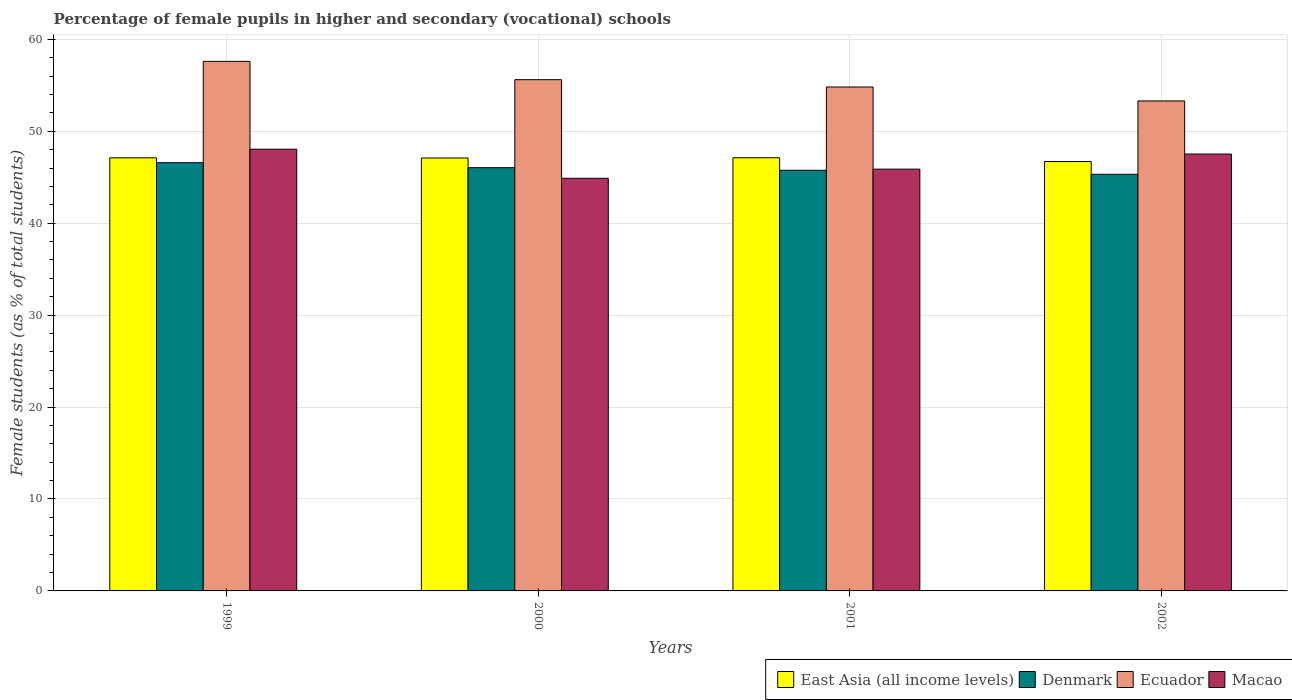Are the number of bars on each tick of the X-axis equal?
Offer a very short reply. Yes. How many bars are there on the 4th tick from the left?
Your response must be concise. 4. In how many cases, is the number of bars for a given year not equal to the number of legend labels?
Keep it short and to the point. 0. What is the percentage of female pupils in higher and secondary schools in Denmark in 2001?
Make the answer very short. 45.76. Across all years, what is the maximum percentage of female pupils in higher and secondary schools in Macao?
Make the answer very short. 48.05. Across all years, what is the minimum percentage of female pupils in higher and secondary schools in East Asia (all income levels)?
Keep it short and to the point. 46.71. In which year was the percentage of female pupils in higher and secondary schools in Ecuador maximum?
Your answer should be very brief. 1999. What is the total percentage of female pupils in higher and secondary schools in East Asia (all income levels) in the graph?
Give a very brief answer. 188.05. What is the difference between the percentage of female pupils in higher and secondary schools in Ecuador in 1999 and that in 2000?
Offer a very short reply. 1.99. What is the difference between the percentage of female pupils in higher and secondary schools in East Asia (all income levels) in 2000 and the percentage of female pupils in higher and secondary schools in Denmark in 2002?
Offer a very short reply. 1.77. What is the average percentage of female pupils in higher and secondary schools in Macao per year?
Your answer should be compact. 46.59. In the year 1999, what is the difference between the percentage of female pupils in higher and secondary schools in Denmark and percentage of female pupils in higher and secondary schools in Macao?
Your answer should be very brief. -1.47. What is the ratio of the percentage of female pupils in higher and secondary schools in Macao in 1999 to that in 2000?
Provide a short and direct response. 1.07. Is the percentage of female pupils in higher and secondary schools in East Asia (all income levels) in 2000 less than that in 2001?
Give a very brief answer. Yes. Is the difference between the percentage of female pupils in higher and secondary schools in Denmark in 2000 and 2002 greater than the difference between the percentage of female pupils in higher and secondary schools in Macao in 2000 and 2002?
Your answer should be compact. Yes. What is the difference between the highest and the second highest percentage of female pupils in higher and secondary schools in Denmark?
Keep it short and to the point. 0.54. What is the difference between the highest and the lowest percentage of female pupils in higher and secondary schools in Ecuador?
Your answer should be compact. 4.31. In how many years, is the percentage of female pupils in higher and secondary schools in Denmark greater than the average percentage of female pupils in higher and secondary schools in Denmark taken over all years?
Give a very brief answer. 2. How many bars are there?
Your response must be concise. 16. Are all the bars in the graph horizontal?
Give a very brief answer. No. How many years are there in the graph?
Your answer should be compact. 4. Does the graph contain any zero values?
Make the answer very short. No. Where does the legend appear in the graph?
Keep it short and to the point. Bottom right. How are the legend labels stacked?
Ensure brevity in your answer.  Horizontal. What is the title of the graph?
Your answer should be very brief. Percentage of female pupils in higher and secondary (vocational) schools. What is the label or title of the Y-axis?
Offer a terse response. Female students (as % of total students). What is the Female students (as % of total students) of East Asia (all income levels) in 1999?
Your response must be concise. 47.11. What is the Female students (as % of total students) in Denmark in 1999?
Your answer should be compact. 46.58. What is the Female students (as % of total students) in Ecuador in 1999?
Your answer should be very brief. 57.61. What is the Female students (as % of total students) in Macao in 1999?
Give a very brief answer. 48.05. What is the Female students (as % of total students) in East Asia (all income levels) in 2000?
Ensure brevity in your answer.  47.1. What is the Female students (as % of total students) of Denmark in 2000?
Keep it short and to the point. 46.04. What is the Female students (as % of total students) in Ecuador in 2000?
Give a very brief answer. 55.62. What is the Female students (as % of total students) in Macao in 2000?
Your response must be concise. 44.89. What is the Female students (as % of total students) of East Asia (all income levels) in 2001?
Offer a terse response. 47.12. What is the Female students (as % of total students) of Denmark in 2001?
Provide a succinct answer. 45.76. What is the Female students (as % of total students) in Ecuador in 2001?
Offer a very short reply. 54.82. What is the Female students (as % of total students) in Macao in 2001?
Your response must be concise. 45.88. What is the Female students (as % of total students) in East Asia (all income levels) in 2002?
Offer a very short reply. 46.71. What is the Female students (as % of total students) in Denmark in 2002?
Give a very brief answer. 45.32. What is the Female students (as % of total students) of Ecuador in 2002?
Offer a terse response. 53.3. What is the Female students (as % of total students) in Macao in 2002?
Make the answer very short. 47.53. Across all years, what is the maximum Female students (as % of total students) in East Asia (all income levels)?
Provide a short and direct response. 47.12. Across all years, what is the maximum Female students (as % of total students) of Denmark?
Provide a short and direct response. 46.58. Across all years, what is the maximum Female students (as % of total students) in Ecuador?
Keep it short and to the point. 57.61. Across all years, what is the maximum Female students (as % of total students) of Macao?
Provide a short and direct response. 48.05. Across all years, what is the minimum Female students (as % of total students) in East Asia (all income levels)?
Keep it short and to the point. 46.71. Across all years, what is the minimum Female students (as % of total students) in Denmark?
Provide a succinct answer. 45.32. Across all years, what is the minimum Female students (as % of total students) in Ecuador?
Keep it short and to the point. 53.3. Across all years, what is the minimum Female students (as % of total students) of Macao?
Ensure brevity in your answer.  44.89. What is the total Female students (as % of total students) in East Asia (all income levels) in the graph?
Offer a very short reply. 188.05. What is the total Female students (as % of total students) in Denmark in the graph?
Provide a short and direct response. 183.71. What is the total Female students (as % of total students) of Ecuador in the graph?
Offer a terse response. 221.35. What is the total Female students (as % of total students) in Macao in the graph?
Make the answer very short. 186.35. What is the difference between the Female students (as % of total students) in East Asia (all income levels) in 1999 and that in 2000?
Make the answer very short. 0.02. What is the difference between the Female students (as % of total students) of Denmark in 1999 and that in 2000?
Your answer should be compact. 0.54. What is the difference between the Female students (as % of total students) in Ecuador in 1999 and that in 2000?
Offer a very short reply. 1.99. What is the difference between the Female students (as % of total students) of Macao in 1999 and that in 2000?
Provide a succinct answer. 3.17. What is the difference between the Female students (as % of total students) of East Asia (all income levels) in 1999 and that in 2001?
Your response must be concise. -0.01. What is the difference between the Female students (as % of total students) in Denmark in 1999 and that in 2001?
Your answer should be compact. 0.83. What is the difference between the Female students (as % of total students) in Ecuador in 1999 and that in 2001?
Provide a short and direct response. 2.79. What is the difference between the Female students (as % of total students) of Macao in 1999 and that in 2001?
Your response must be concise. 2.17. What is the difference between the Female students (as % of total students) of East Asia (all income levels) in 1999 and that in 2002?
Give a very brief answer. 0.4. What is the difference between the Female students (as % of total students) in Denmark in 1999 and that in 2002?
Make the answer very short. 1.26. What is the difference between the Female students (as % of total students) of Ecuador in 1999 and that in 2002?
Give a very brief answer. 4.31. What is the difference between the Female students (as % of total students) in Macao in 1999 and that in 2002?
Make the answer very short. 0.53. What is the difference between the Female students (as % of total students) of East Asia (all income levels) in 2000 and that in 2001?
Make the answer very short. -0.03. What is the difference between the Female students (as % of total students) in Denmark in 2000 and that in 2001?
Ensure brevity in your answer.  0.28. What is the difference between the Female students (as % of total students) of Ecuador in 2000 and that in 2001?
Your answer should be very brief. 0.8. What is the difference between the Female students (as % of total students) in Macao in 2000 and that in 2001?
Your answer should be compact. -1. What is the difference between the Female students (as % of total students) of East Asia (all income levels) in 2000 and that in 2002?
Keep it short and to the point. 0.38. What is the difference between the Female students (as % of total students) of Denmark in 2000 and that in 2002?
Provide a succinct answer. 0.72. What is the difference between the Female students (as % of total students) in Ecuador in 2000 and that in 2002?
Keep it short and to the point. 2.31. What is the difference between the Female students (as % of total students) of Macao in 2000 and that in 2002?
Offer a very short reply. -2.64. What is the difference between the Female students (as % of total students) of East Asia (all income levels) in 2001 and that in 2002?
Provide a short and direct response. 0.41. What is the difference between the Female students (as % of total students) in Denmark in 2001 and that in 2002?
Your answer should be very brief. 0.44. What is the difference between the Female students (as % of total students) of Ecuador in 2001 and that in 2002?
Make the answer very short. 1.52. What is the difference between the Female students (as % of total students) of Macao in 2001 and that in 2002?
Provide a succinct answer. -1.64. What is the difference between the Female students (as % of total students) of East Asia (all income levels) in 1999 and the Female students (as % of total students) of Denmark in 2000?
Provide a short and direct response. 1.07. What is the difference between the Female students (as % of total students) of East Asia (all income levels) in 1999 and the Female students (as % of total students) of Ecuador in 2000?
Ensure brevity in your answer.  -8.5. What is the difference between the Female students (as % of total students) of East Asia (all income levels) in 1999 and the Female students (as % of total students) of Macao in 2000?
Offer a very short reply. 2.23. What is the difference between the Female students (as % of total students) in Denmark in 1999 and the Female students (as % of total students) in Ecuador in 2000?
Offer a terse response. -9.03. What is the difference between the Female students (as % of total students) in Denmark in 1999 and the Female students (as % of total students) in Macao in 2000?
Your response must be concise. 1.7. What is the difference between the Female students (as % of total students) of Ecuador in 1999 and the Female students (as % of total students) of Macao in 2000?
Your answer should be compact. 12.72. What is the difference between the Female students (as % of total students) of East Asia (all income levels) in 1999 and the Female students (as % of total students) of Denmark in 2001?
Offer a terse response. 1.35. What is the difference between the Female students (as % of total students) in East Asia (all income levels) in 1999 and the Female students (as % of total students) in Ecuador in 2001?
Ensure brevity in your answer.  -7.71. What is the difference between the Female students (as % of total students) in East Asia (all income levels) in 1999 and the Female students (as % of total students) in Macao in 2001?
Ensure brevity in your answer.  1.23. What is the difference between the Female students (as % of total students) of Denmark in 1999 and the Female students (as % of total students) of Ecuador in 2001?
Give a very brief answer. -8.24. What is the difference between the Female students (as % of total students) in Denmark in 1999 and the Female students (as % of total students) in Macao in 2001?
Your answer should be compact. 0.7. What is the difference between the Female students (as % of total students) in Ecuador in 1999 and the Female students (as % of total students) in Macao in 2001?
Keep it short and to the point. 11.72. What is the difference between the Female students (as % of total students) of East Asia (all income levels) in 1999 and the Female students (as % of total students) of Denmark in 2002?
Offer a terse response. 1.79. What is the difference between the Female students (as % of total students) of East Asia (all income levels) in 1999 and the Female students (as % of total students) of Ecuador in 2002?
Keep it short and to the point. -6.19. What is the difference between the Female students (as % of total students) in East Asia (all income levels) in 1999 and the Female students (as % of total students) in Macao in 2002?
Provide a short and direct response. -0.41. What is the difference between the Female students (as % of total students) of Denmark in 1999 and the Female students (as % of total students) of Ecuador in 2002?
Give a very brief answer. -6.72. What is the difference between the Female students (as % of total students) of Denmark in 1999 and the Female students (as % of total students) of Macao in 2002?
Your answer should be very brief. -0.94. What is the difference between the Female students (as % of total students) of Ecuador in 1999 and the Female students (as % of total students) of Macao in 2002?
Your response must be concise. 10.08. What is the difference between the Female students (as % of total students) in East Asia (all income levels) in 2000 and the Female students (as % of total students) in Denmark in 2001?
Your answer should be compact. 1.34. What is the difference between the Female students (as % of total students) in East Asia (all income levels) in 2000 and the Female students (as % of total students) in Ecuador in 2001?
Provide a succinct answer. -7.72. What is the difference between the Female students (as % of total students) in East Asia (all income levels) in 2000 and the Female students (as % of total students) in Macao in 2001?
Give a very brief answer. 1.21. What is the difference between the Female students (as % of total students) of Denmark in 2000 and the Female students (as % of total students) of Ecuador in 2001?
Make the answer very short. -8.78. What is the difference between the Female students (as % of total students) in Denmark in 2000 and the Female students (as % of total students) in Macao in 2001?
Keep it short and to the point. 0.16. What is the difference between the Female students (as % of total students) of Ecuador in 2000 and the Female students (as % of total students) of Macao in 2001?
Ensure brevity in your answer.  9.73. What is the difference between the Female students (as % of total students) in East Asia (all income levels) in 2000 and the Female students (as % of total students) in Denmark in 2002?
Keep it short and to the point. 1.77. What is the difference between the Female students (as % of total students) of East Asia (all income levels) in 2000 and the Female students (as % of total students) of Ecuador in 2002?
Your response must be concise. -6.21. What is the difference between the Female students (as % of total students) in East Asia (all income levels) in 2000 and the Female students (as % of total students) in Macao in 2002?
Make the answer very short. -0.43. What is the difference between the Female students (as % of total students) in Denmark in 2000 and the Female students (as % of total students) in Ecuador in 2002?
Keep it short and to the point. -7.26. What is the difference between the Female students (as % of total students) in Denmark in 2000 and the Female students (as % of total students) in Macao in 2002?
Make the answer very short. -1.49. What is the difference between the Female students (as % of total students) of Ecuador in 2000 and the Female students (as % of total students) of Macao in 2002?
Your response must be concise. 8.09. What is the difference between the Female students (as % of total students) of East Asia (all income levels) in 2001 and the Female students (as % of total students) of Denmark in 2002?
Provide a short and direct response. 1.8. What is the difference between the Female students (as % of total students) of East Asia (all income levels) in 2001 and the Female students (as % of total students) of Ecuador in 2002?
Your answer should be very brief. -6.18. What is the difference between the Female students (as % of total students) in East Asia (all income levels) in 2001 and the Female students (as % of total students) in Macao in 2002?
Provide a succinct answer. -0.4. What is the difference between the Female students (as % of total students) in Denmark in 2001 and the Female students (as % of total students) in Ecuador in 2002?
Your response must be concise. -7.54. What is the difference between the Female students (as % of total students) of Denmark in 2001 and the Female students (as % of total students) of Macao in 2002?
Provide a short and direct response. -1.77. What is the difference between the Female students (as % of total students) of Ecuador in 2001 and the Female students (as % of total students) of Macao in 2002?
Provide a succinct answer. 7.29. What is the average Female students (as % of total students) of East Asia (all income levels) per year?
Your answer should be compact. 47.01. What is the average Female students (as % of total students) of Denmark per year?
Ensure brevity in your answer.  45.93. What is the average Female students (as % of total students) of Ecuador per year?
Offer a terse response. 55.34. What is the average Female students (as % of total students) in Macao per year?
Provide a short and direct response. 46.59. In the year 1999, what is the difference between the Female students (as % of total students) in East Asia (all income levels) and Female students (as % of total students) in Denmark?
Your answer should be very brief. 0.53. In the year 1999, what is the difference between the Female students (as % of total students) of East Asia (all income levels) and Female students (as % of total students) of Ecuador?
Provide a succinct answer. -10.5. In the year 1999, what is the difference between the Female students (as % of total students) of East Asia (all income levels) and Female students (as % of total students) of Macao?
Make the answer very short. -0.94. In the year 1999, what is the difference between the Female students (as % of total students) of Denmark and Female students (as % of total students) of Ecuador?
Your answer should be very brief. -11.02. In the year 1999, what is the difference between the Female students (as % of total students) in Denmark and Female students (as % of total students) in Macao?
Ensure brevity in your answer.  -1.47. In the year 1999, what is the difference between the Female students (as % of total students) of Ecuador and Female students (as % of total students) of Macao?
Your response must be concise. 9.56. In the year 2000, what is the difference between the Female students (as % of total students) of East Asia (all income levels) and Female students (as % of total students) of Denmark?
Your answer should be very brief. 1.05. In the year 2000, what is the difference between the Female students (as % of total students) of East Asia (all income levels) and Female students (as % of total students) of Ecuador?
Make the answer very short. -8.52. In the year 2000, what is the difference between the Female students (as % of total students) in East Asia (all income levels) and Female students (as % of total students) in Macao?
Keep it short and to the point. 2.21. In the year 2000, what is the difference between the Female students (as % of total students) of Denmark and Female students (as % of total students) of Ecuador?
Give a very brief answer. -9.57. In the year 2000, what is the difference between the Female students (as % of total students) in Denmark and Female students (as % of total students) in Macao?
Your answer should be compact. 1.16. In the year 2000, what is the difference between the Female students (as % of total students) of Ecuador and Female students (as % of total students) of Macao?
Offer a terse response. 10.73. In the year 2001, what is the difference between the Female students (as % of total students) of East Asia (all income levels) and Female students (as % of total students) of Denmark?
Provide a succinct answer. 1.36. In the year 2001, what is the difference between the Female students (as % of total students) of East Asia (all income levels) and Female students (as % of total students) of Ecuador?
Ensure brevity in your answer.  -7.7. In the year 2001, what is the difference between the Female students (as % of total students) in East Asia (all income levels) and Female students (as % of total students) in Macao?
Ensure brevity in your answer.  1.24. In the year 2001, what is the difference between the Female students (as % of total students) of Denmark and Female students (as % of total students) of Ecuador?
Keep it short and to the point. -9.06. In the year 2001, what is the difference between the Female students (as % of total students) of Denmark and Female students (as % of total students) of Macao?
Your response must be concise. -0.12. In the year 2001, what is the difference between the Female students (as % of total students) in Ecuador and Female students (as % of total students) in Macao?
Provide a short and direct response. 8.94. In the year 2002, what is the difference between the Female students (as % of total students) in East Asia (all income levels) and Female students (as % of total students) in Denmark?
Your response must be concise. 1.39. In the year 2002, what is the difference between the Female students (as % of total students) in East Asia (all income levels) and Female students (as % of total students) in Ecuador?
Keep it short and to the point. -6.59. In the year 2002, what is the difference between the Female students (as % of total students) of East Asia (all income levels) and Female students (as % of total students) of Macao?
Provide a succinct answer. -0.81. In the year 2002, what is the difference between the Female students (as % of total students) in Denmark and Female students (as % of total students) in Ecuador?
Keep it short and to the point. -7.98. In the year 2002, what is the difference between the Female students (as % of total students) in Denmark and Female students (as % of total students) in Macao?
Your answer should be very brief. -2.2. In the year 2002, what is the difference between the Female students (as % of total students) in Ecuador and Female students (as % of total students) in Macao?
Provide a short and direct response. 5.78. What is the ratio of the Female students (as % of total students) of Denmark in 1999 to that in 2000?
Your answer should be compact. 1.01. What is the ratio of the Female students (as % of total students) of Ecuador in 1999 to that in 2000?
Ensure brevity in your answer.  1.04. What is the ratio of the Female students (as % of total students) in Macao in 1999 to that in 2000?
Your answer should be very brief. 1.07. What is the ratio of the Female students (as % of total students) in Denmark in 1999 to that in 2001?
Ensure brevity in your answer.  1.02. What is the ratio of the Female students (as % of total students) of Ecuador in 1999 to that in 2001?
Make the answer very short. 1.05. What is the ratio of the Female students (as % of total students) in Macao in 1999 to that in 2001?
Give a very brief answer. 1.05. What is the ratio of the Female students (as % of total students) in East Asia (all income levels) in 1999 to that in 2002?
Your answer should be compact. 1.01. What is the ratio of the Female students (as % of total students) in Denmark in 1999 to that in 2002?
Keep it short and to the point. 1.03. What is the ratio of the Female students (as % of total students) in Ecuador in 1999 to that in 2002?
Your answer should be compact. 1.08. What is the ratio of the Female students (as % of total students) of Macao in 1999 to that in 2002?
Provide a short and direct response. 1.01. What is the ratio of the Female students (as % of total students) in Ecuador in 2000 to that in 2001?
Offer a very short reply. 1.01. What is the ratio of the Female students (as % of total students) in Macao in 2000 to that in 2001?
Provide a short and direct response. 0.98. What is the ratio of the Female students (as % of total students) in East Asia (all income levels) in 2000 to that in 2002?
Make the answer very short. 1.01. What is the ratio of the Female students (as % of total students) of Denmark in 2000 to that in 2002?
Your answer should be compact. 1.02. What is the ratio of the Female students (as % of total students) in Ecuador in 2000 to that in 2002?
Ensure brevity in your answer.  1.04. What is the ratio of the Female students (as % of total students) of East Asia (all income levels) in 2001 to that in 2002?
Offer a terse response. 1.01. What is the ratio of the Female students (as % of total students) of Denmark in 2001 to that in 2002?
Offer a terse response. 1.01. What is the ratio of the Female students (as % of total students) of Ecuador in 2001 to that in 2002?
Your answer should be very brief. 1.03. What is the ratio of the Female students (as % of total students) in Macao in 2001 to that in 2002?
Keep it short and to the point. 0.97. What is the difference between the highest and the second highest Female students (as % of total students) in East Asia (all income levels)?
Keep it short and to the point. 0.01. What is the difference between the highest and the second highest Female students (as % of total students) in Denmark?
Offer a terse response. 0.54. What is the difference between the highest and the second highest Female students (as % of total students) in Ecuador?
Make the answer very short. 1.99. What is the difference between the highest and the second highest Female students (as % of total students) in Macao?
Your response must be concise. 0.53. What is the difference between the highest and the lowest Female students (as % of total students) of East Asia (all income levels)?
Your answer should be compact. 0.41. What is the difference between the highest and the lowest Female students (as % of total students) in Denmark?
Your answer should be compact. 1.26. What is the difference between the highest and the lowest Female students (as % of total students) in Ecuador?
Keep it short and to the point. 4.31. What is the difference between the highest and the lowest Female students (as % of total students) of Macao?
Make the answer very short. 3.17. 